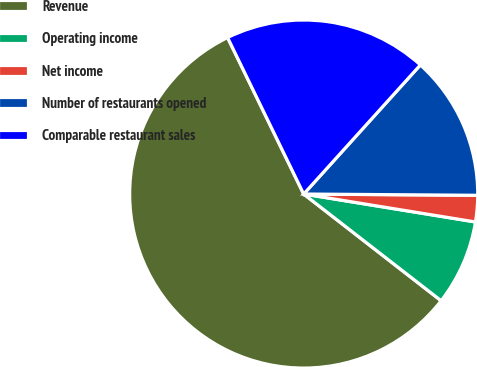Convert chart to OTSL. <chart><loc_0><loc_0><loc_500><loc_500><pie_chart><fcel>Revenue<fcel>Operating income<fcel>Net income<fcel>Number of restaurants opened<fcel>Comparable restaurant sales<nl><fcel>57.29%<fcel>7.94%<fcel>2.45%<fcel>13.42%<fcel>18.9%<nl></chart> 